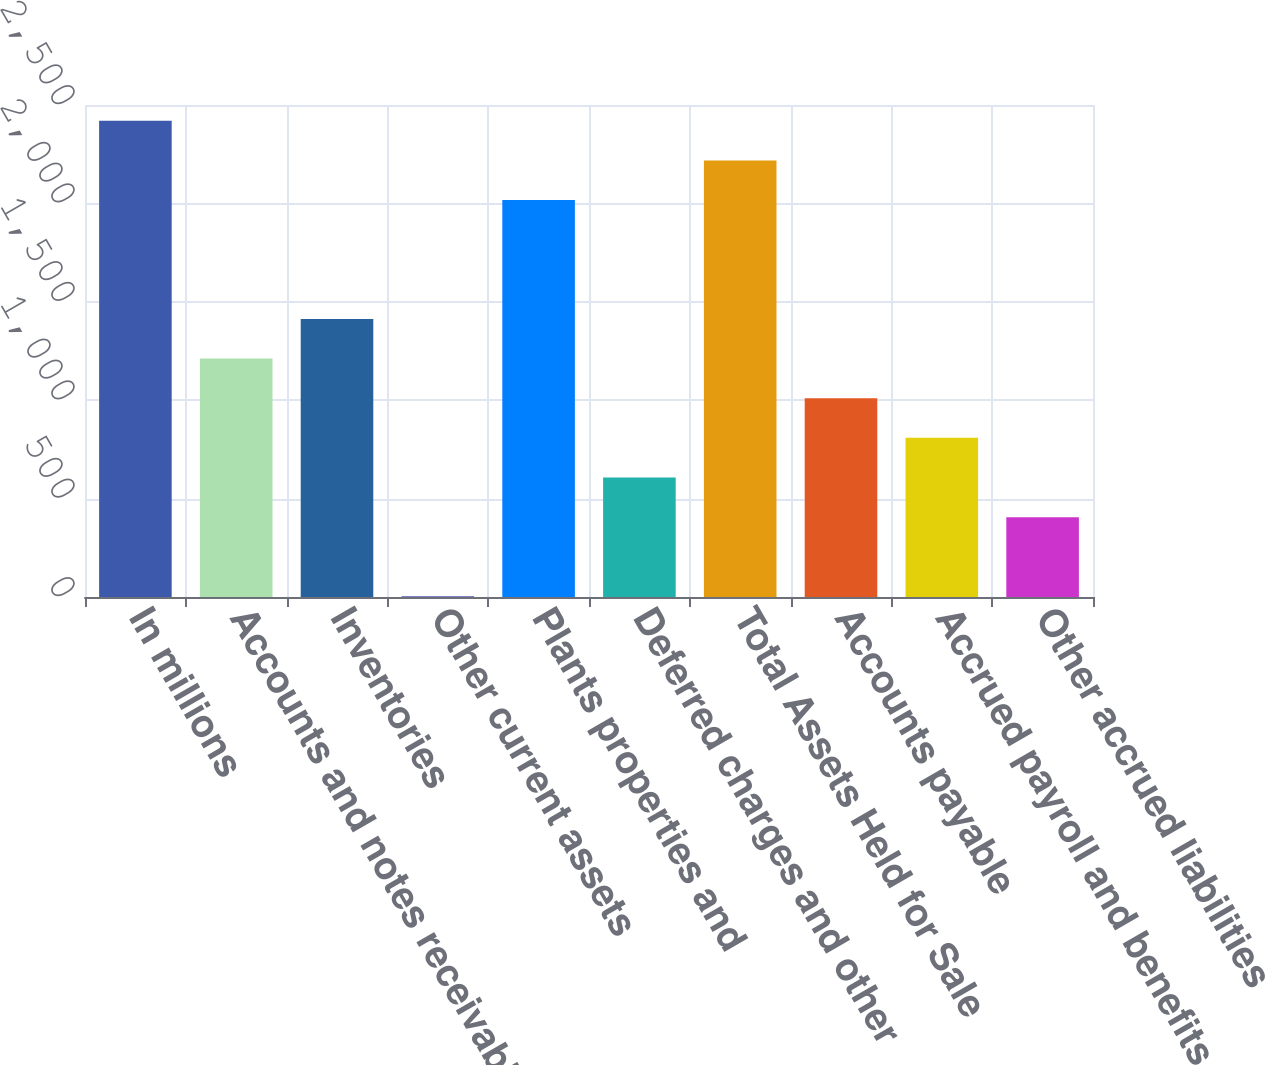Convert chart. <chart><loc_0><loc_0><loc_500><loc_500><bar_chart><fcel>In millions<fcel>Accounts and notes receivable<fcel>Inventories<fcel>Other current assets<fcel>Plants properties and<fcel>Deferred charges and other<fcel>Total Assets Held for Sale<fcel>Accounts payable<fcel>Accrued payroll and benefits<fcel>Other accrued liabilities<nl><fcel>2419.8<fcel>1211.4<fcel>1412.8<fcel>3<fcel>2017<fcel>607.2<fcel>2218.4<fcel>1010<fcel>808.6<fcel>405.8<nl></chart> 